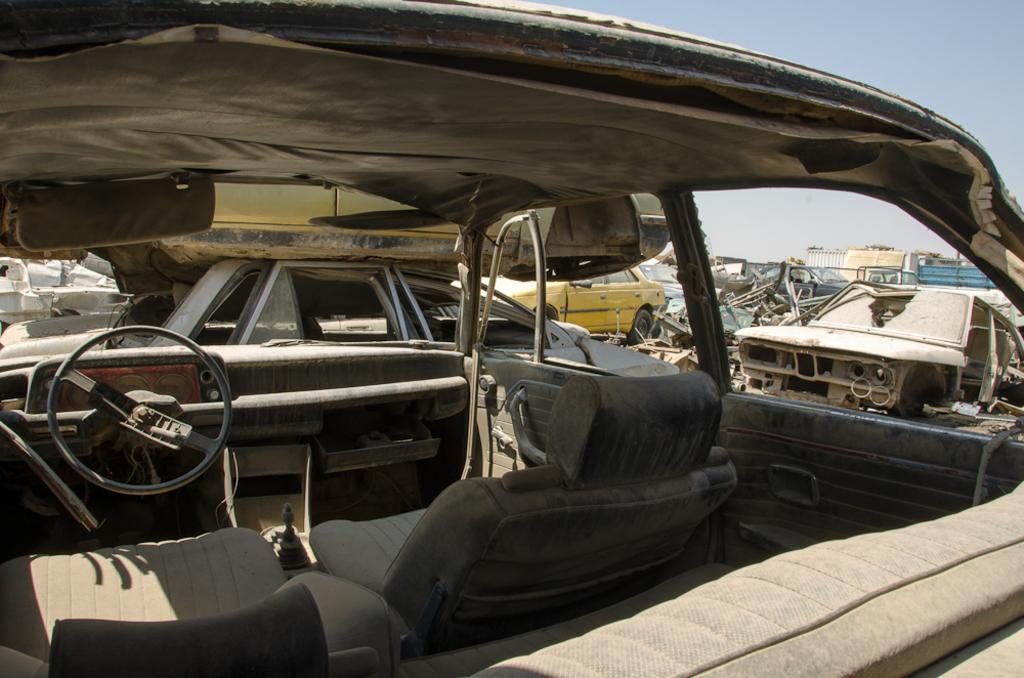What type of vehicles can be seen in the image? There are old rusted cars in the image. What else is present in the image besides the cars? There are scrap materials in the image. What can be seen in the background of the image? The sky is visible in the background of the image. What vein is visible in the image? There is no vein visible in the image; it features old rusted cars and scrap materials. 